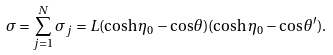<formula> <loc_0><loc_0><loc_500><loc_500>\sigma = \sum _ { j = 1 } ^ { N } \sigma _ { j } = L ( \cosh \eta _ { 0 } - \cos \theta ) ( \cosh \eta _ { 0 } - \cos \theta ^ { \prime } ) .</formula> 